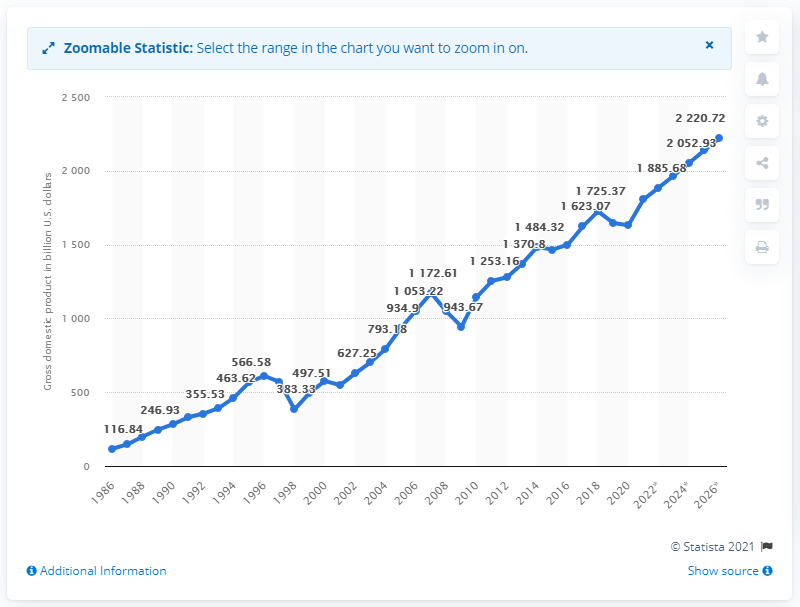Point out several critical features in this image. In 2020, South Korea's GDP was valued at 1630.87 billion dollars. 